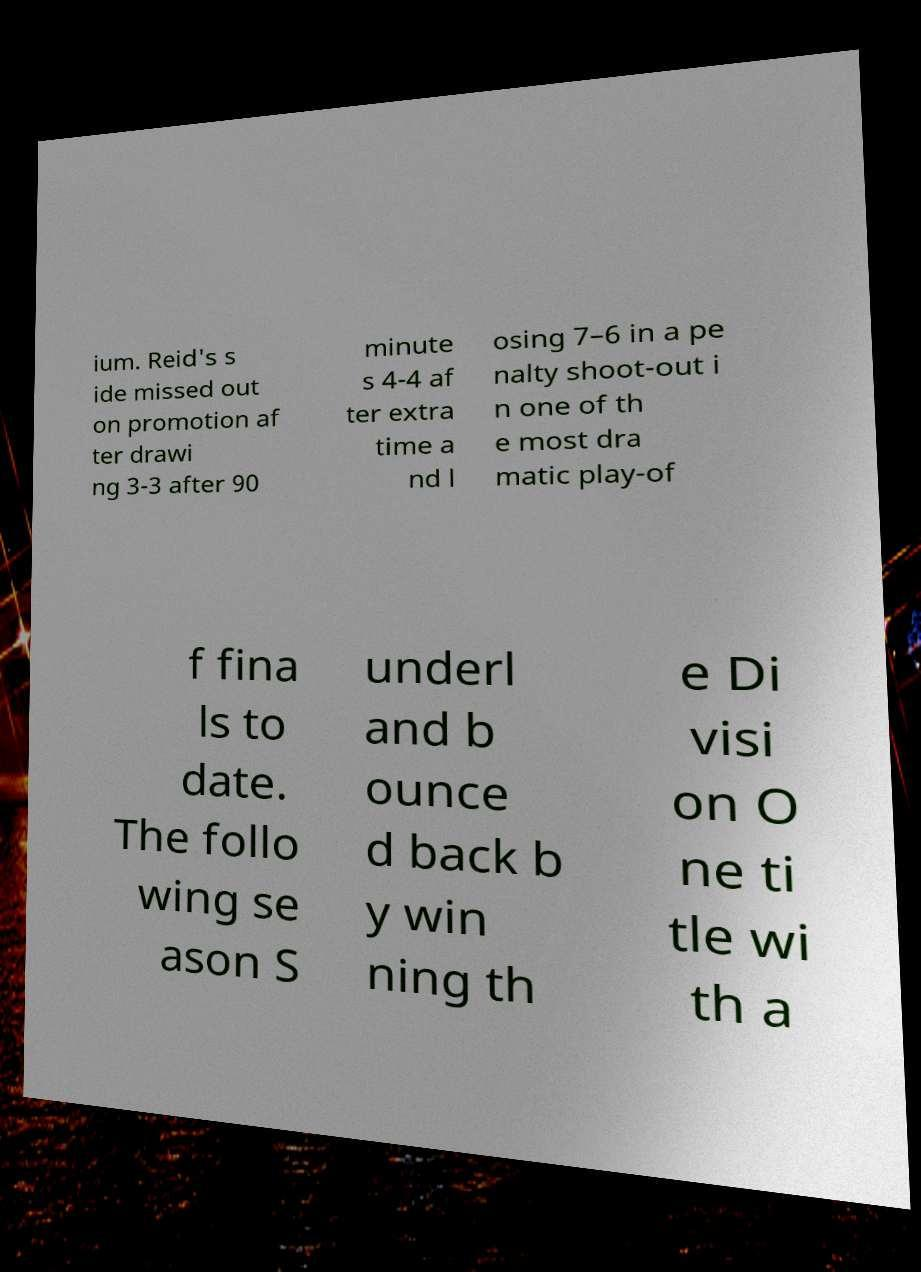Please read and relay the text visible in this image. What does it say? ium. Reid's s ide missed out on promotion af ter drawi ng 3-3 after 90 minute s 4-4 af ter extra time a nd l osing 7–6 in a pe nalty shoot-out i n one of th e most dra matic play-of f fina ls to date. The follo wing se ason S underl and b ounce d back b y win ning th e Di visi on O ne ti tle wi th a 